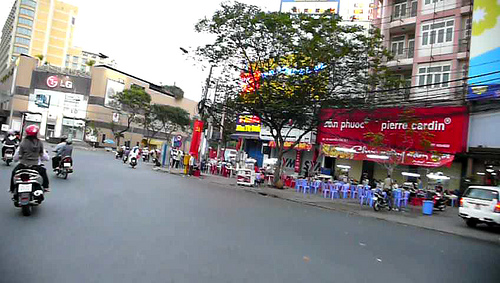Is that store white? No, the store is not white; it features prominently in red colors. 